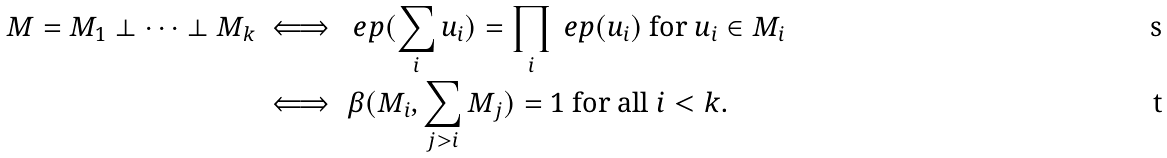Convert formula to latex. <formula><loc_0><loc_0><loc_500><loc_500>M = M _ { 1 } \perp \dots \perp M _ { k } & \iff \ e p ( \sum _ { i } u _ { i } ) = \prod _ { i } \ e p ( u _ { i } ) \text { for } u _ { i } \in M _ { i } \\ & \iff \beta ( M _ { i } , \sum _ { j > i } M _ { j } ) = 1 \text { for all } i < k .</formula> 